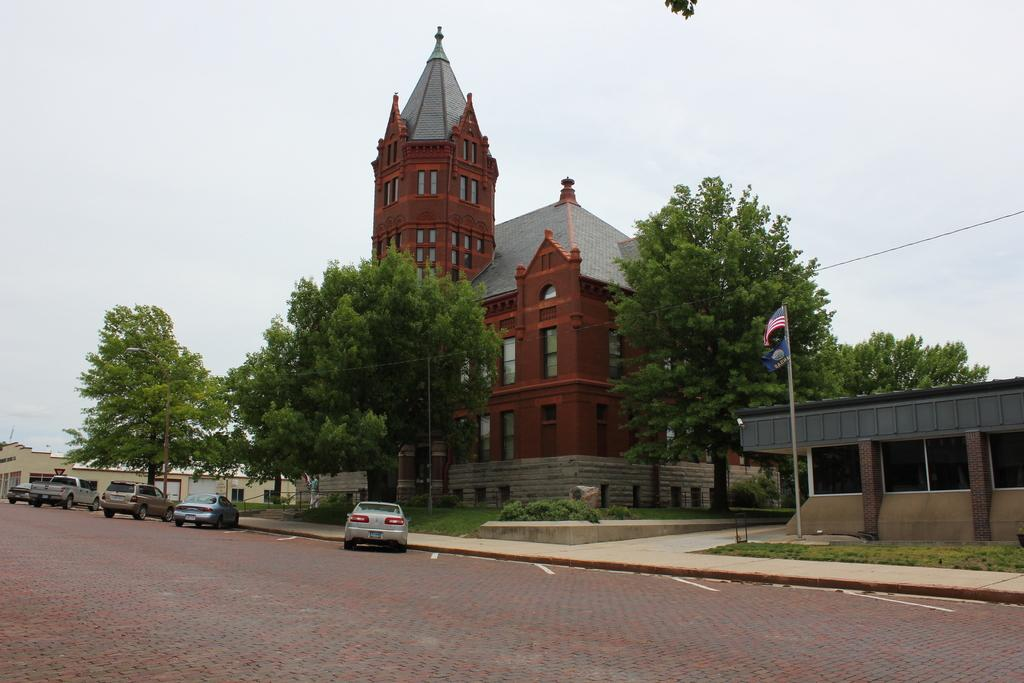What is in the foreground of the image? There is a road in the foreground of the image. What can be seen in the background of the image? There are trees, houses, vehicles, and the sky visible in the background of the image. What type of structures are present in the background? There are houses in the background of the image. What else is visible in the background besides the houses? There are trees, vehicles, and the sky visible in the background of the image. Where is the faucet located in the image? There is no faucet present in the image. How many rings are visible on the vehicles in the image? There are no rings visible on the vehicles in the image. 